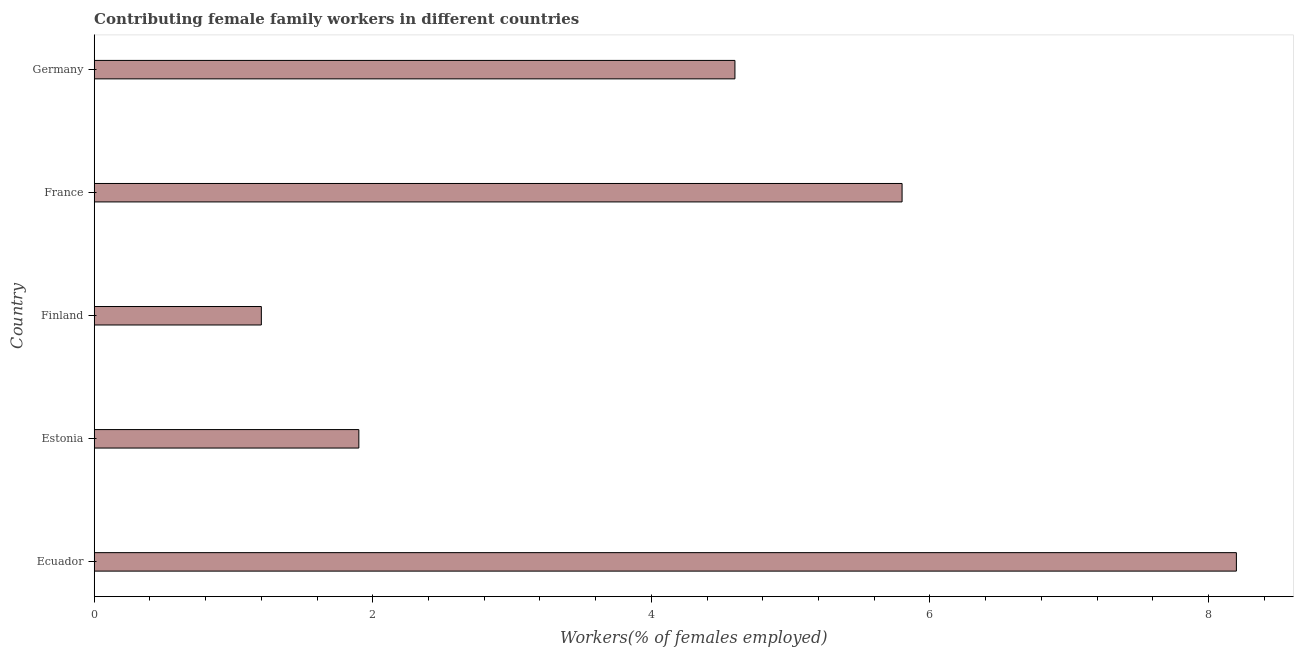Does the graph contain any zero values?
Your answer should be compact. No. What is the title of the graph?
Your response must be concise. Contributing female family workers in different countries. What is the label or title of the X-axis?
Make the answer very short. Workers(% of females employed). What is the label or title of the Y-axis?
Provide a succinct answer. Country. What is the contributing female family workers in Ecuador?
Ensure brevity in your answer.  8.2. Across all countries, what is the maximum contributing female family workers?
Your answer should be compact. 8.2. Across all countries, what is the minimum contributing female family workers?
Ensure brevity in your answer.  1.2. In which country was the contributing female family workers maximum?
Ensure brevity in your answer.  Ecuador. What is the sum of the contributing female family workers?
Provide a short and direct response. 21.7. What is the difference between the contributing female family workers in Estonia and France?
Make the answer very short. -3.9. What is the average contributing female family workers per country?
Provide a succinct answer. 4.34. What is the median contributing female family workers?
Offer a very short reply. 4.6. In how many countries, is the contributing female family workers greater than 7.2 %?
Make the answer very short. 1. What is the ratio of the contributing female family workers in France to that in Germany?
Provide a short and direct response. 1.26. Is the contributing female family workers in Ecuador less than that in France?
Provide a succinct answer. No. Is the sum of the contributing female family workers in Estonia and Finland greater than the maximum contributing female family workers across all countries?
Your response must be concise. No. What is the difference between the highest and the lowest contributing female family workers?
Offer a very short reply. 7. Are the values on the major ticks of X-axis written in scientific E-notation?
Keep it short and to the point. No. What is the Workers(% of females employed) in Ecuador?
Ensure brevity in your answer.  8.2. What is the Workers(% of females employed) in Estonia?
Provide a succinct answer. 1.9. What is the Workers(% of females employed) of Finland?
Offer a terse response. 1.2. What is the Workers(% of females employed) of France?
Give a very brief answer. 5.8. What is the Workers(% of females employed) in Germany?
Offer a terse response. 4.6. What is the difference between the Workers(% of females employed) in Ecuador and Finland?
Offer a terse response. 7. What is the difference between the Workers(% of females employed) in Ecuador and France?
Ensure brevity in your answer.  2.4. What is the difference between the Workers(% of females employed) in Ecuador and Germany?
Your answer should be compact. 3.6. What is the difference between the Workers(% of females employed) in Estonia and Germany?
Offer a terse response. -2.7. What is the difference between the Workers(% of females employed) in Finland and Germany?
Your response must be concise. -3.4. What is the ratio of the Workers(% of females employed) in Ecuador to that in Estonia?
Your answer should be compact. 4.32. What is the ratio of the Workers(% of females employed) in Ecuador to that in Finland?
Make the answer very short. 6.83. What is the ratio of the Workers(% of females employed) in Ecuador to that in France?
Your response must be concise. 1.41. What is the ratio of the Workers(% of females employed) in Ecuador to that in Germany?
Make the answer very short. 1.78. What is the ratio of the Workers(% of females employed) in Estonia to that in Finland?
Ensure brevity in your answer.  1.58. What is the ratio of the Workers(% of females employed) in Estonia to that in France?
Give a very brief answer. 0.33. What is the ratio of the Workers(% of females employed) in Estonia to that in Germany?
Keep it short and to the point. 0.41. What is the ratio of the Workers(% of females employed) in Finland to that in France?
Offer a very short reply. 0.21. What is the ratio of the Workers(% of females employed) in Finland to that in Germany?
Give a very brief answer. 0.26. What is the ratio of the Workers(% of females employed) in France to that in Germany?
Ensure brevity in your answer.  1.26. 